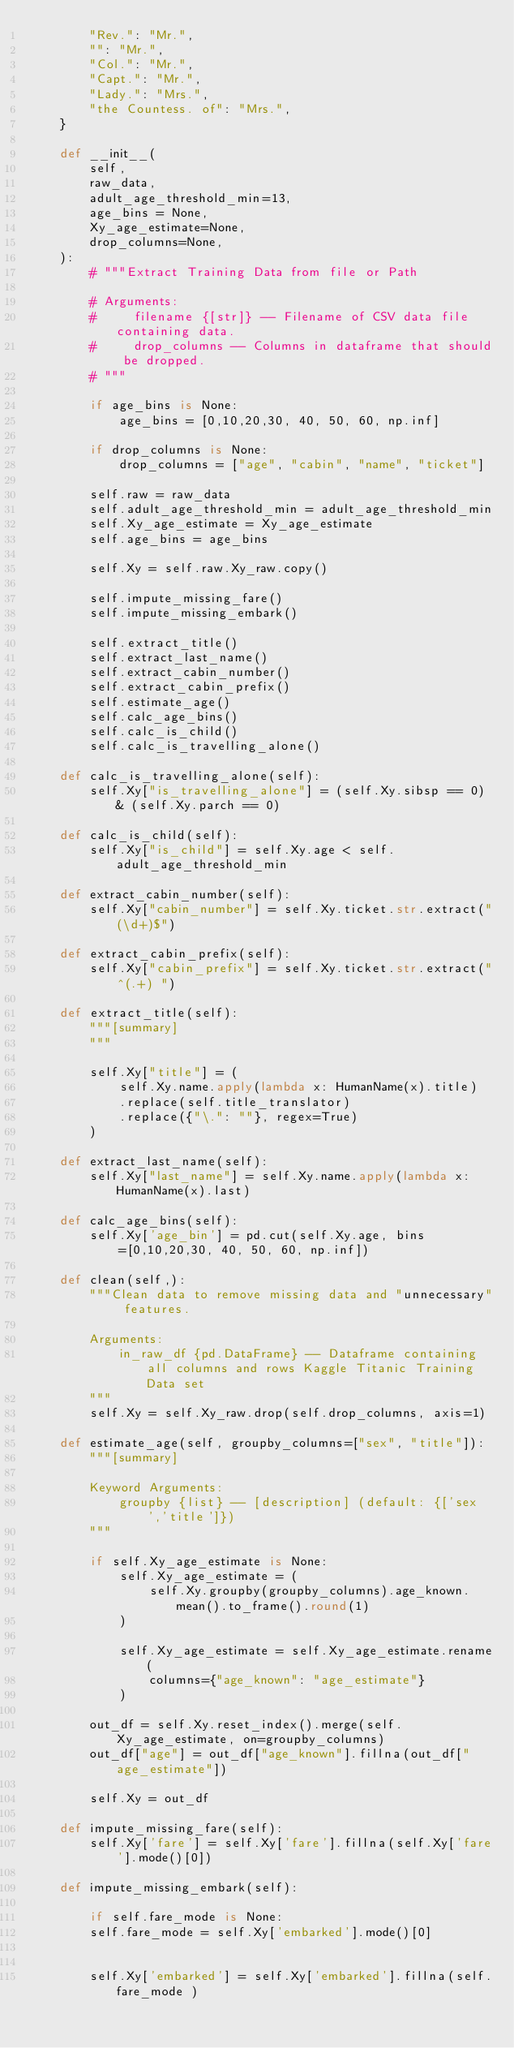<code> <loc_0><loc_0><loc_500><loc_500><_Python_>        "Rev.": "Mr.",
        "": "Mr.",
        "Col.": "Mr.",
        "Capt.": "Mr.",
        "Lady.": "Mrs.",
        "the Countess. of": "Mrs.",
    }

    def __init__(
        self,
        raw_data,
        adult_age_threshold_min=13,
        age_bins = None,
        Xy_age_estimate=None,
        drop_columns=None,
    ):
        # """Extract Training Data from file or Path

        # Arguments:
        #     filename {[str]} -- Filename of CSV data file containing data.
        #     drop_columns -- Columns in dataframe that should be dropped.
        # """

        if age_bins is None:
            age_bins = [0,10,20,30, 40, 50, 60, np.inf]

        if drop_columns is None:
            drop_columns = ["age", "cabin", "name", "ticket"]

        self.raw = raw_data
        self.adult_age_threshold_min = adult_age_threshold_min
        self.Xy_age_estimate = Xy_age_estimate
        self.age_bins = age_bins

        self.Xy = self.raw.Xy_raw.copy()

        self.impute_missing_fare()
        self.impute_missing_embark()

        self.extract_title()
        self.extract_last_name()
        self.extract_cabin_number()
        self.extract_cabin_prefix()
        self.estimate_age()
        self.calc_age_bins()
        self.calc_is_child()
        self.calc_is_travelling_alone()

    def calc_is_travelling_alone(self):
        self.Xy["is_travelling_alone"] = (self.Xy.sibsp == 0) & (self.Xy.parch == 0)

    def calc_is_child(self):
        self.Xy["is_child"] = self.Xy.age < self.adult_age_threshold_min

    def extract_cabin_number(self):
        self.Xy["cabin_number"] = self.Xy.ticket.str.extract("(\d+)$")

    def extract_cabin_prefix(self):
        self.Xy["cabin_prefix"] = self.Xy.ticket.str.extract("^(.+) ")

    def extract_title(self):
        """[summary]
        """

        self.Xy["title"] = (
            self.Xy.name.apply(lambda x: HumanName(x).title)
            .replace(self.title_translator)
            .replace({"\.": ""}, regex=True)
        )

    def extract_last_name(self):
        self.Xy["last_name"] = self.Xy.name.apply(lambda x: HumanName(x).last)

    def calc_age_bins(self):
        self.Xy['age_bin'] = pd.cut(self.Xy.age, bins=[0,10,20,30, 40, 50, 60, np.inf])

    def clean(self,):
        """Clean data to remove missing data and "unnecessary" features.
        
        Arguments:
            in_raw_df {pd.DataFrame} -- Dataframe containing all columns and rows Kaggle Titanic Training Data set
        """
        self.Xy = self.Xy_raw.drop(self.drop_columns, axis=1)

    def estimate_age(self, groupby_columns=["sex", "title"]):
        """[summary]
        
        Keyword Arguments:
            groupby {list} -- [description] (default: {['sex','title']})
        """

        if self.Xy_age_estimate is None:
            self.Xy_age_estimate = (
                self.Xy.groupby(groupby_columns).age_known.mean().to_frame().round(1)
            )

            self.Xy_age_estimate = self.Xy_age_estimate.rename(
                columns={"age_known": "age_estimate"}
            )

        out_df = self.Xy.reset_index().merge(self.Xy_age_estimate, on=groupby_columns)
        out_df["age"] = out_df["age_known"].fillna(out_df["age_estimate"])

        self.Xy = out_df

    def impute_missing_fare(self):
        self.Xy['fare'] = self.Xy['fare'].fillna(self.Xy['fare'].mode()[0])

    def impute_missing_embark(self):

        if self.fare_mode is None:
        self.fare_mode = self.Xy['embarked'].mode()[0]


        self.Xy['embarked'] = self.Xy['embarked'].fillna(self.fare_mode )
</code> 